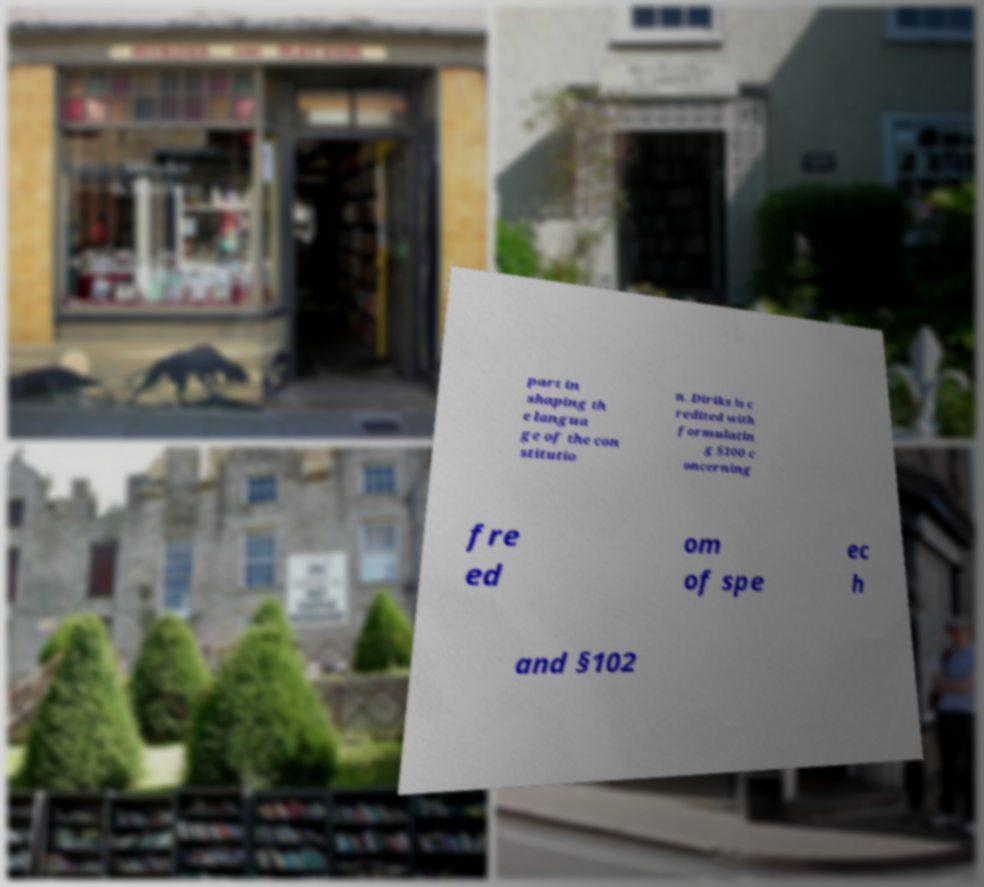Can you read and provide the text displayed in the image?This photo seems to have some interesting text. Can you extract and type it out for me? part in shaping th e langua ge of the con stitutio n. Diriks is c redited with formulatin g §100 c oncerning fre ed om of spe ec h and §102 